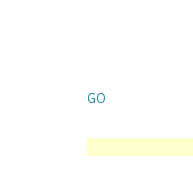Convert code to text. <code><loc_0><loc_0><loc_500><loc_500><_SQL_>

GO</code> 